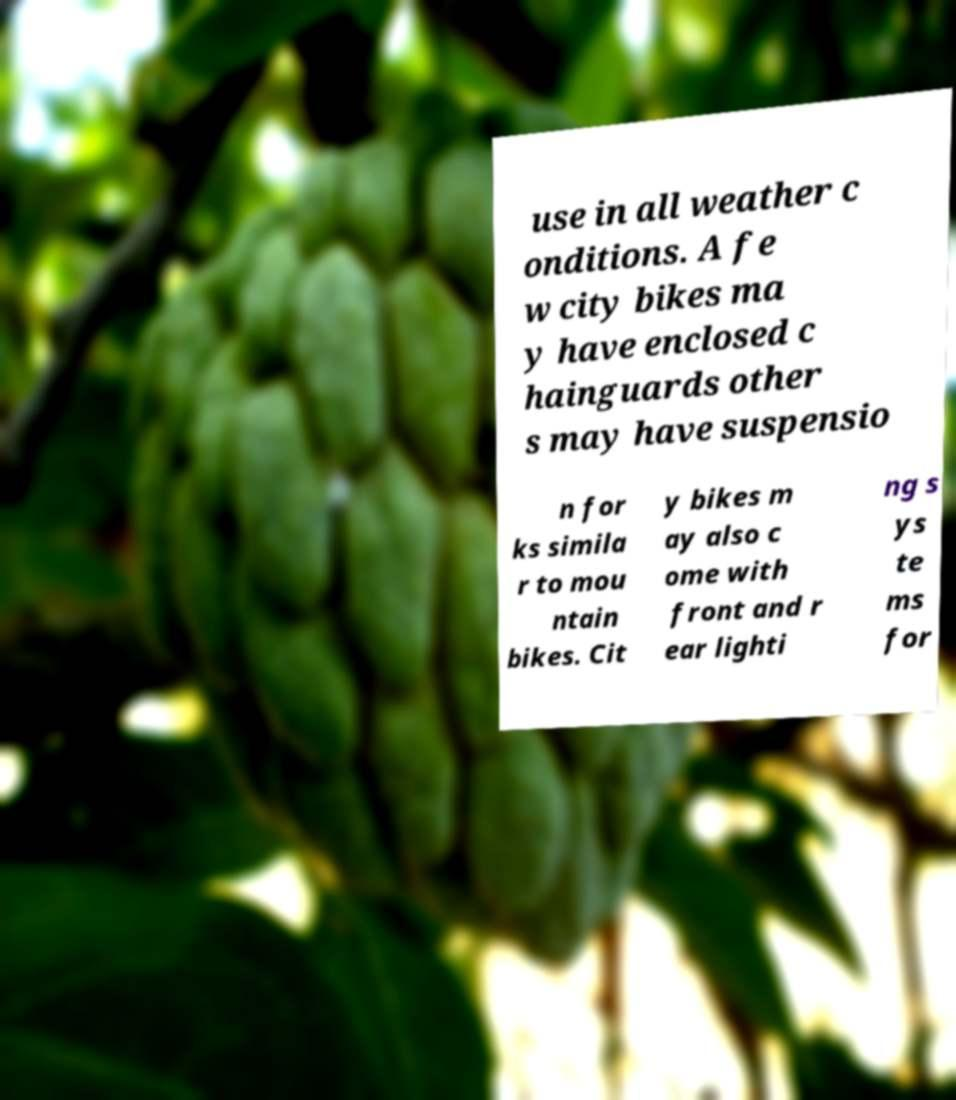For documentation purposes, I need the text within this image transcribed. Could you provide that? use in all weather c onditions. A fe w city bikes ma y have enclosed c hainguards other s may have suspensio n for ks simila r to mou ntain bikes. Cit y bikes m ay also c ome with front and r ear lighti ng s ys te ms for 